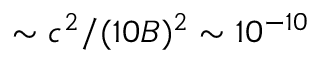Convert formula to latex. <formula><loc_0><loc_0><loc_500><loc_500>\sim c ^ { 2 } / ( 1 0 B ) ^ { 2 } \sim 1 0 ^ { - 1 0 }</formula> 